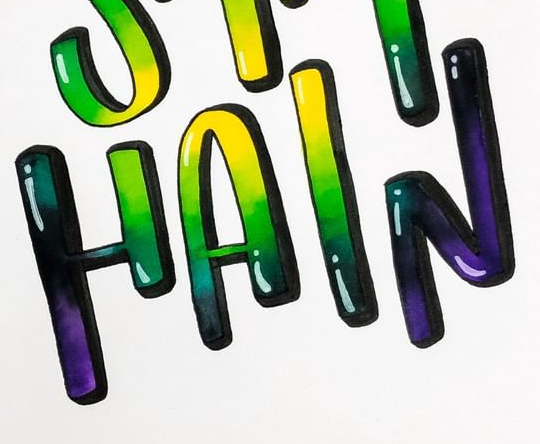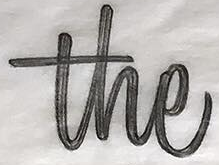What text is displayed in these images sequentially, separated by a semicolon? HAIN; the 